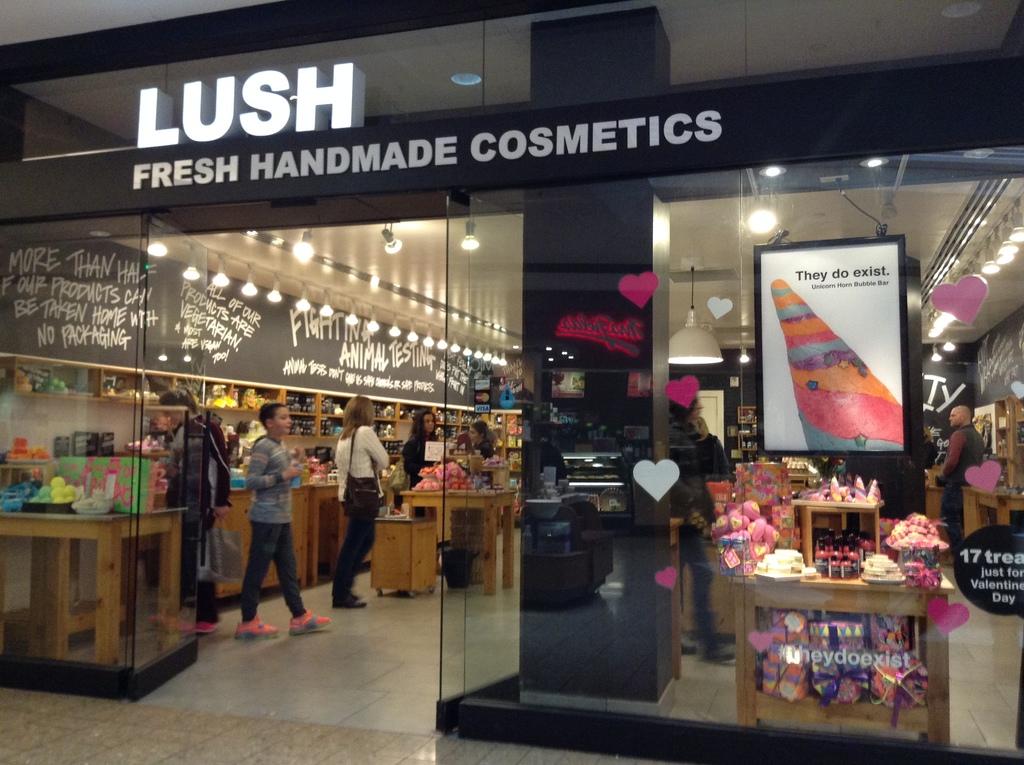What store is this?
Offer a terse response. Lush. 